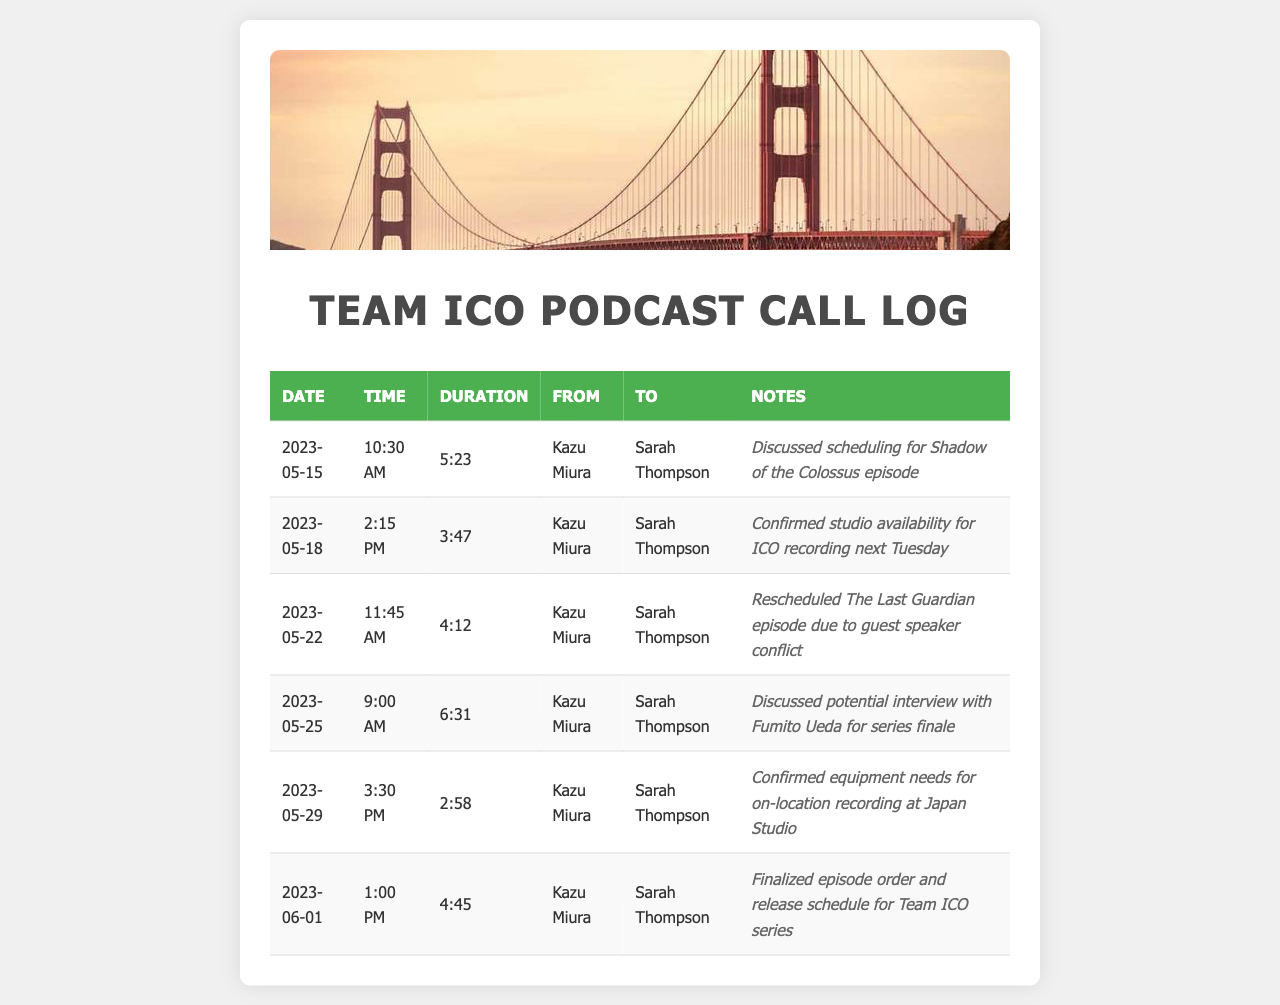What is the date of the first call? The first call in the log is recorded on May 15, 2023.
Answer: May 15, 2023 Who is the producer receiving the calls? All calls are directed to Sarah Thompson, who is the recipient in each entry.
Answer: Sarah Thompson What was discussed in the May 25th call? The notes indicate that they discussed a potential interview with Fumito Ueda for the series finale during this call.
Answer: Potential interview with Fumito Ueda How long was the call on May 29th? The duration of the call on May 29th is listed as 2 minutes and 58 seconds.
Answer: 2:58 What is the total number of calls logged? There are 6 entries recorded in the call log, representing the number of calls made.
Answer: 6 Which episode was rescheduled, and why? The Last Guardian episode was rescheduled due to a conflict with a guest speaker.
Answer: The Last Guardian episode, guest speaker conflict What time was the latest call made? The last recorded call in the log took place at 1:00 PM on June 1, 2023.
Answer: 1:00 PM What equipment needs were confirmed during the May 29th call? The notes state that equipment needs for an on-location recording at Japan Studio were confirmed during this call.
Answer: On-location recording equipment at Japan Studio 